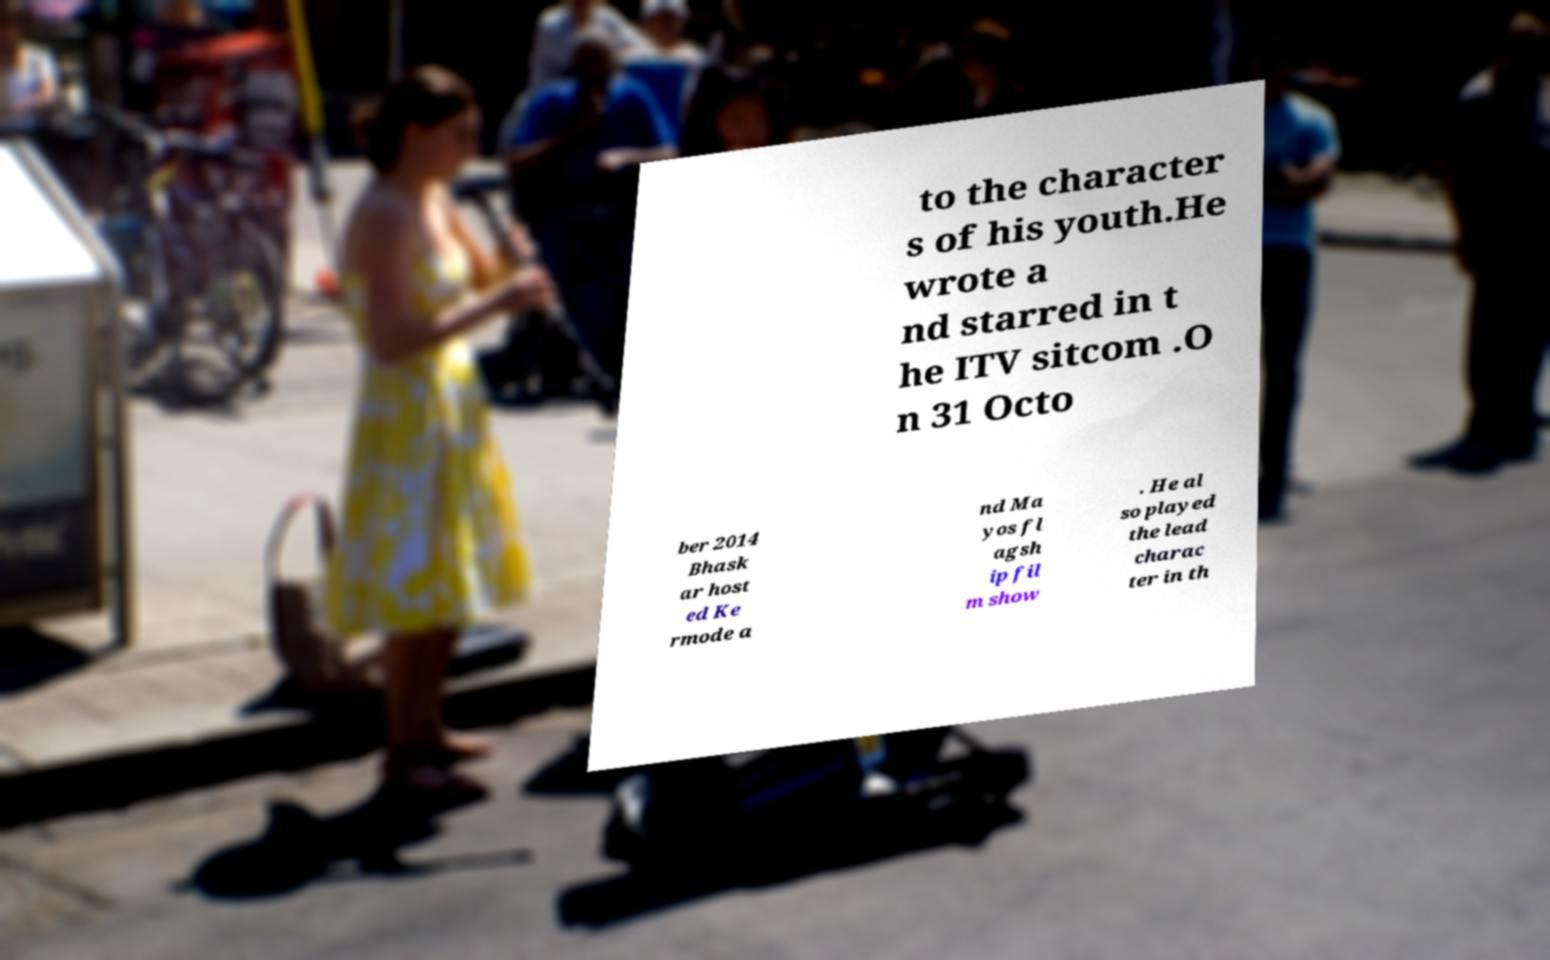Could you assist in decoding the text presented in this image and type it out clearly? to the character s of his youth.He wrote a nd starred in t he ITV sitcom .O n 31 Octo ber 2014 Bhask ar host ed Ke rmode a nd Ma yos fl agsh ip fil m show . He al so played the lead charac ter in th 